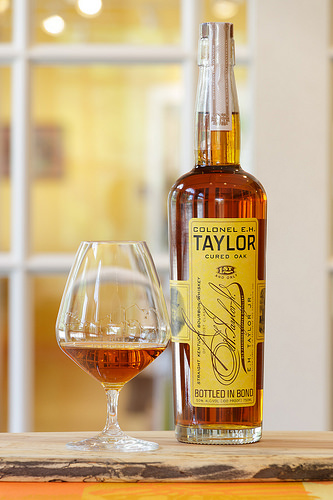<image>
Is the bottle to the left of the board? No. The bottle is not to the left of the board. From this viewpoint, they have a different horizontal relationship. Where is the painting in relation to the bottle? Is it behind the bottle? Yes. From this viewpoint, the painting is positioned behind the bottle, with the bottle partially or fully occluding the painting. 